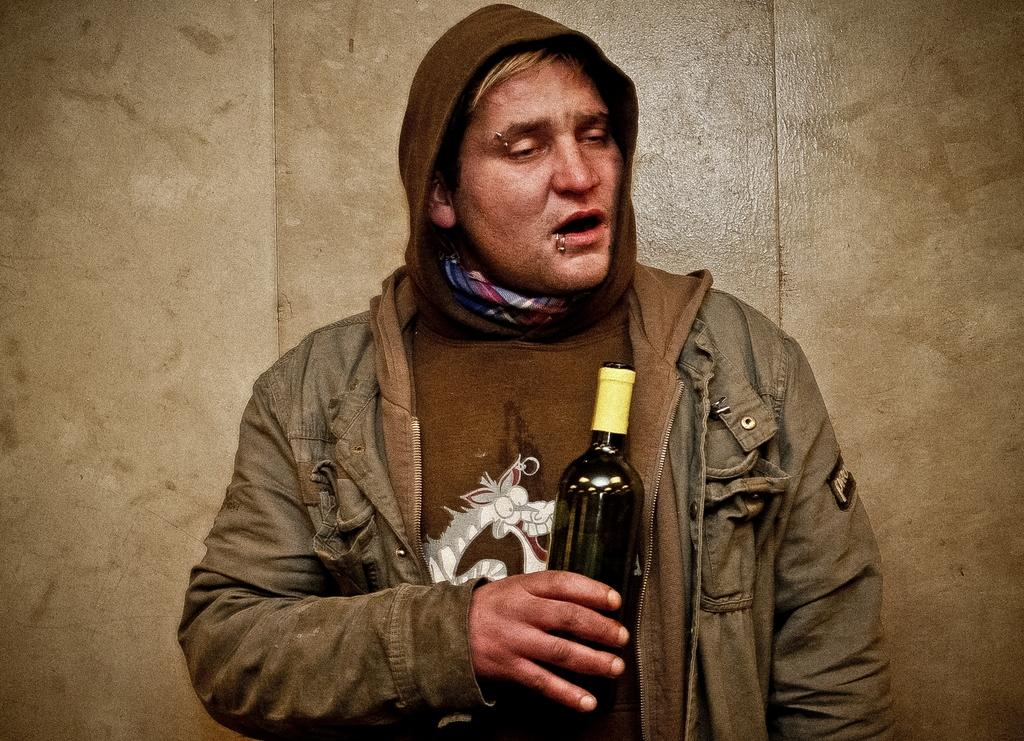What is the main subject of the image? There is a person in the image. What is the person doing in the image? The person is standing. What object is the person holding in the image? The person is holding a wine bottle in his hands. What can be seen in the background of the image? There is a wall in the background of the image. What type of paste is the person applying to the wall in the image? There is no paste or activity related to applying paste visible in the image. 